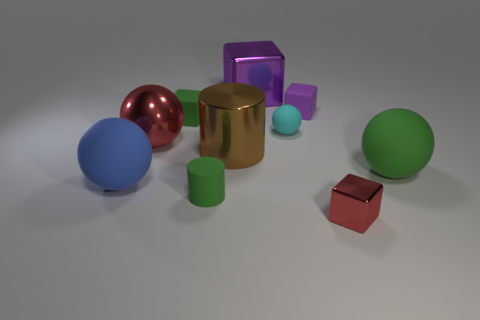Subtract all tiny blocks. How many blocks are left? 1 Subtract all cyan balls. How many purple cubes are left? 2 Subtract 2 cubes. How many cubes are left? 2 Subtract all purple blocks. How many blocks are left? 2 Subtract all blocks. How many objects are left? 6 Subtract all green blocks. Subtract all green cylinders. How many blocks are left? 3 Subtract all metal cylinders. Subtract all large metal spheres. How many objects are left? 8 Add 5 green rubber cylinders. How many green rubber cylinders are left? 6 Add 3 purple shiny spheres. How many purple shiny spheres exist? 3 Subtract 1 green cylinders. How many objects are left? 9 